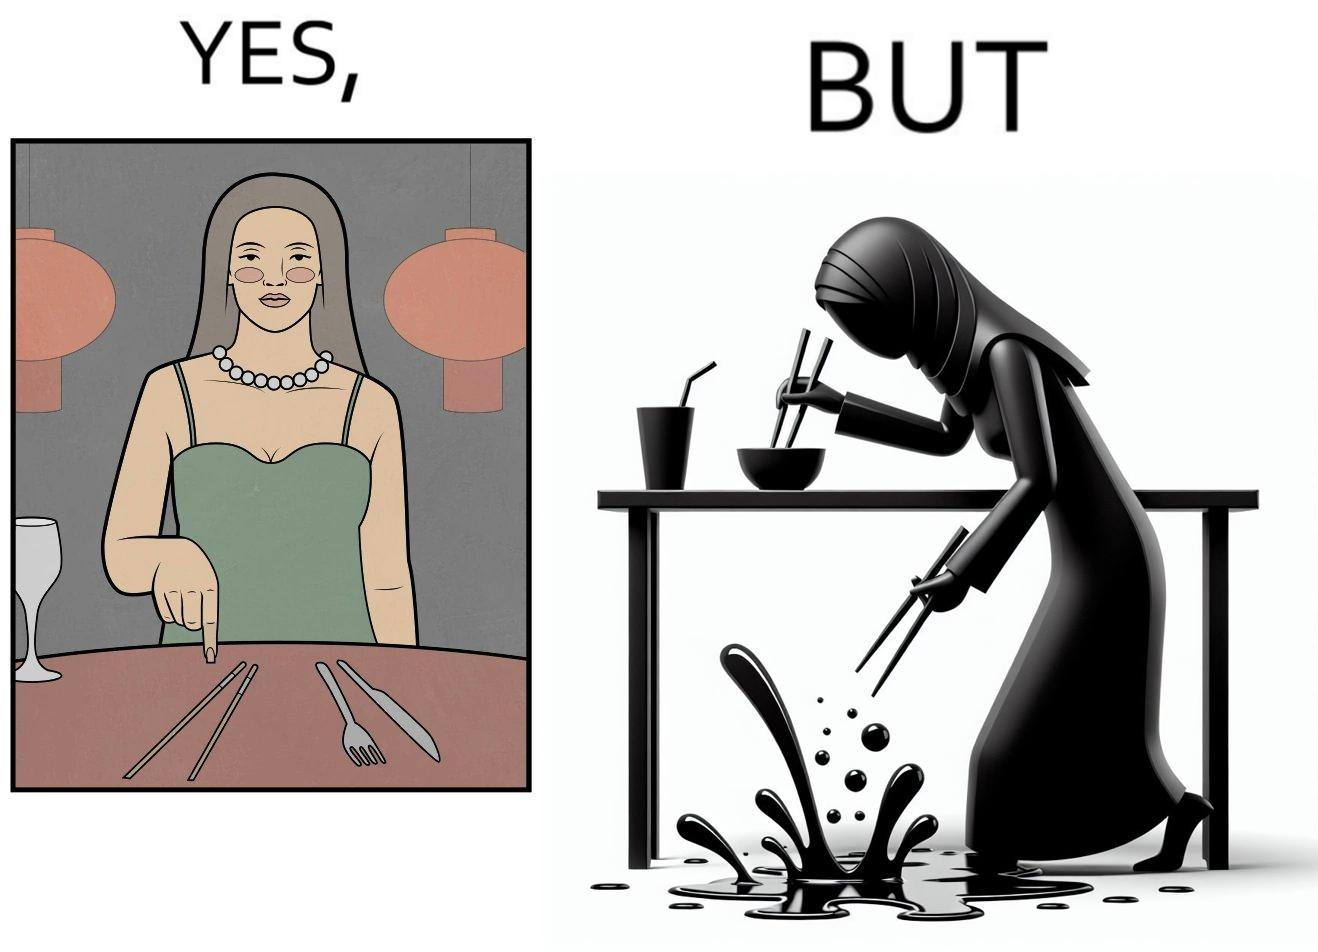Describe the satirical element in this image. The image is satirical because even thought the woman is not able to eat food with chopstick properly, she chooses it over fork and knife to look sophisticaed. 